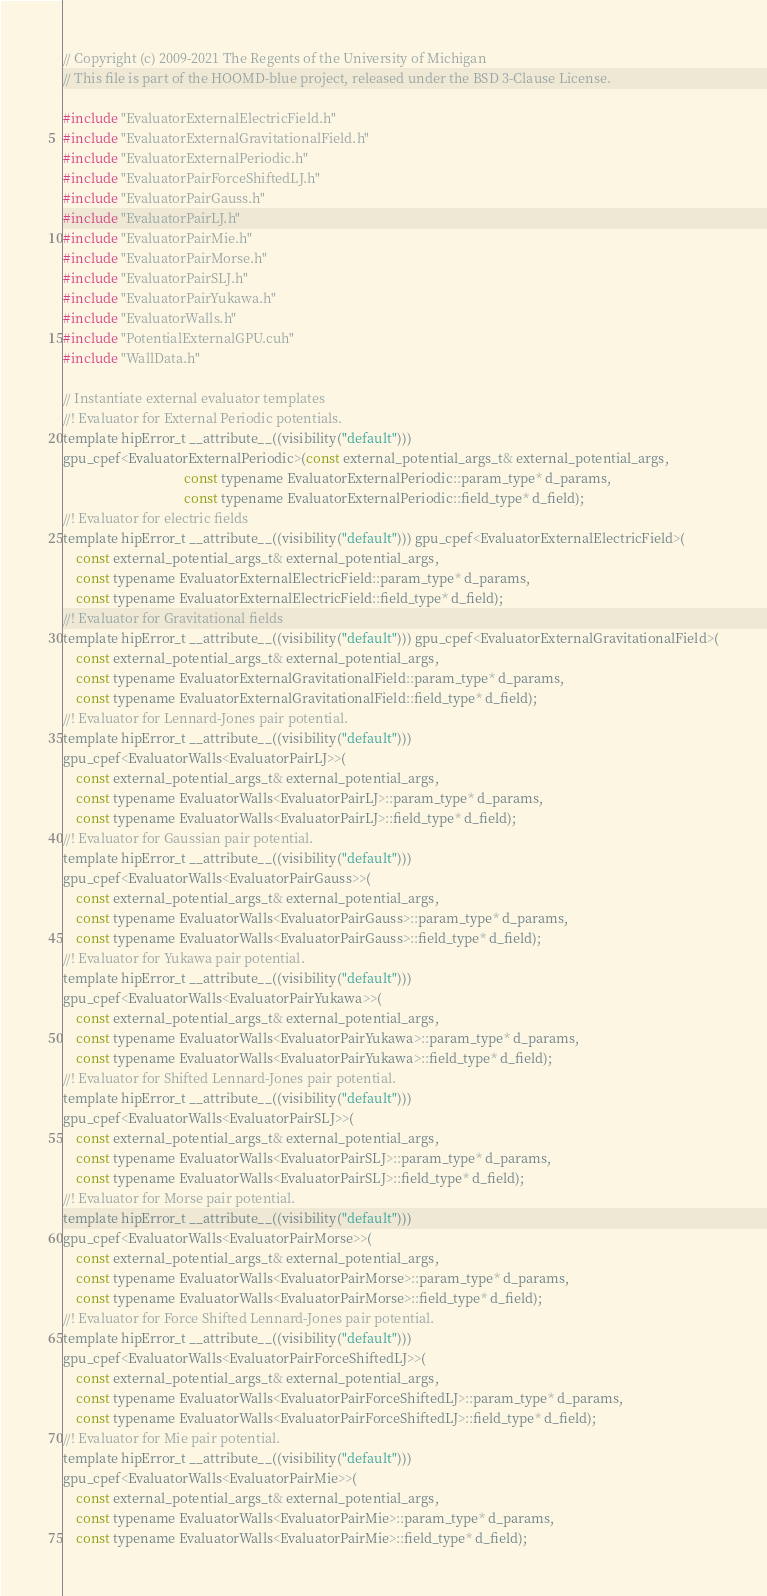Convert code to text. <code><loc_0><loc_0><loc_500><loc_500><_Cuda_>// Copyright (c) 2009-2021 The Regents of the University of Michigan
// This file is part of the HOOMD-blue project, released under the BSD 3-Clause License.

#include "EvaluatorExternalElectricField.h"
#include "EvaluatorExternalGravitationalField.h"
#include "EvaluatorExternalPeriodic.h"
#include "EvaluatorPairForceShiftedLJ.h"
#include "EvaluatorPairGauss.h"
#include "EvaluatorPairLJ.h"
#include "EvaluatorPairMie.h"
#include "EvaluatorPairMorse.h"
#include "EvaluatorPairSLJ.h"
#include "EvaluatorPairYukawa.h"
#include "EvaluatorWalls.h"
#include "PotentialExternalGPU.cuh"
#include "WallData.h"

// Instantiate external evaluator templates
//! Evaluator for External Periodic potentials.
template hipError_t __attribute__((visibility("default")))
gpu_cpef<EvaluatorExternalPeriodic>(const external_potential_args_t& external_potential_args,
                                    const typename EvaluatorExternalPeriodic::param_type* d_params,
                                    const typename EvaluatorExternalPeriodic::field_type* d_field);
//! Evaluator for electric fields
template hipError_t __attribute__((visibility("default"))) gpu_cpef<EvaluatorExternalElectricField>(
    const external_potential_args_t& external_potential_args,
    const typename EvaluatorExternalElectricField::param_type* d_params,
    const typename EvaluatorExternalElectricField::field_type* d_field);
//! Evaluator for Gravitational fields
template hipError_t __attribute__((visibility("default"))) gpu_cpef<EvaluatorExternalGravitationalField>(
    const external_potential_args_t& external_potential_args,
    const typename EvaluatorExternalGravitationalField::param_type* d_params,
    const typename EvaluatorExternalGravitationalField::field_type* d_field);
//! Evaluator for Lennard-Jones pair potential.
template hipError_t __attribute__((visibility("default")))
gpu_cpef<EvaluatorWalls<EvaluatorPairLJ>>(
    const external_potential_args_t& external_potential_args,
    const typename EvaluatorWalls<EvaluatorPairLJ>::param_type* d_params,
    const typename EvaluatorWalls<EvaluatorPairLJ>::field_type* d_field);
//! Evaluator for Gaussian pair potential.
template hipError_t __attribute__((visibility("default")))
gpu_cpef<EvaluatorWalls<EvaluatorPairGauss>>(
    const external_potential_args_t& external_potential_args,
    const typename EvaluatorWalls<EvaluatorPairGauss>::param_type* d_params,
    const typename EvaluatorWalls<EvaluatorPairGauss>::field_type* d_field);
//! Evaluator for Yukawa pair potential.
template hipError_t __attribute__((visibility("default")))
gpu_cpef<EvaluatorWalls<EvaluatorPairYukawa>>(
    const external_potential_args_t& external_potential_args,
    const typename EvaluatorWalls<EvaluatorPairYukawa>::param_type* d_params,
    const typename EvaluatorWalls<EvaluatorPairYukawa>::field_type* d_field);
//! Evaluator for Shifted Lennard-Jones pair potential.
template hipError_t __attribute__((visibility("default")))
gpu_cpef<EvaluatorWalls<EvaluatorPairSLJ>>(
    const external_potential_args_t& external_potential_args,
    const typename EvaluatorWalls<EvaluatorPairSLJ>::param_type* d_params,
    const typename EvaluatorWalls<EvaluatorPairSLJ>::field_type* d_field);
//! Evaluator for Morse pair potential.
template hipError_t __attribute__((visibility("default")))
gpu_cpef<EvaluatorWalls<EvaluatorPairMorse>>(
    const external_potential_args_t& external_potential_args,
    const typename EvaluatorWalls<EvaluatorPairMorse>::param_type* d_params,
    const typename EvaluatorWalls<EvaluatorPairMorse>::field_type* d_field);
//! Evaluator for Force Shifted Lennard-Jones pair potential.
template hipError_t __attribute__((visibility("default")))
gpu_cpef<EvaluatorWalls<EvaluatorPairForceShiftedLJ>>(
    const external_potential_args_t& external_potential_args,
    const typename EvaluatorWalls<EvaluatorPairForceShiftedLJ>::param_type* d_params,
    const typename EvaluatorWalls<EvaluatorPairForceShiftedLJ>::field_type* d_field);
//! Evaluator for Mie pair potential.
template hipError_t __attribute__((visibility("default")))
gpu_cpef<EvaluatorWalls<EvaluatorPairMie>>(
    const external_potential_args_t& external_potential_args,
    const typename EvaluatorWalls<EvaluatorPairMie>::param_type* d_params,
    const typename EvaluatorWalls<EvaluatorPairMie>::field_type* d_field);
</code> 